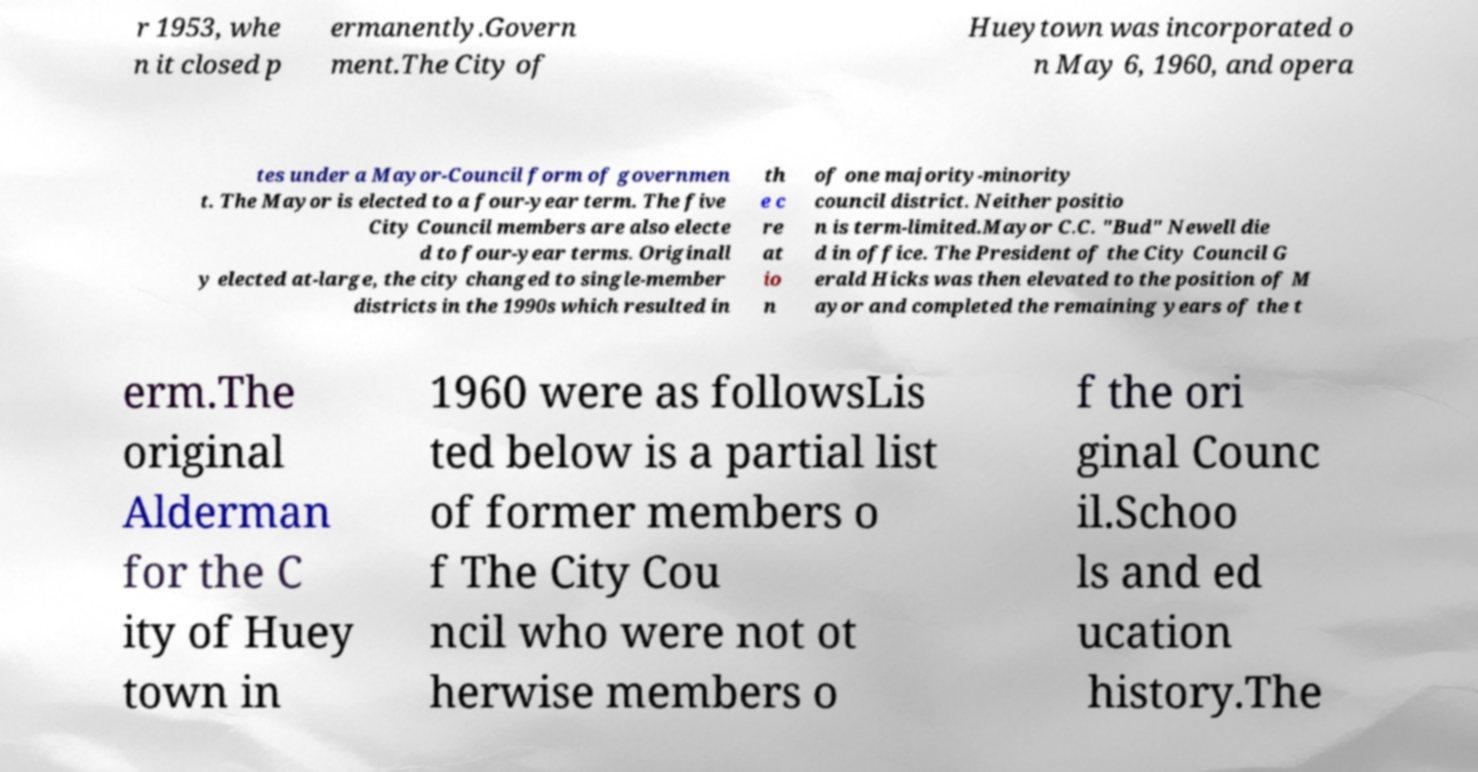Please identify and transcribe the text found in this image. r 1953, whe n it closed p ermanently.Govern ment.The City of Hueytown was incorporated o n May 6, 1960, and opera tes under a Mayor-Council form of governmen t. The Mayor is elected to a four-year term. The five City Council members are also electe d to four-year terms. Originall y elected at-large, the city changed to single-member districts in the 1990s which resulted in th e c re at io n of one majority-minority council district. Neither positio n is term-limited.Mayor C.C. "Bud" Newell die d in office. The President of the City Council G erald Hicks was then elevated to the position of M ayor and completed the remaining years of the t erm.The original Alderman for the C ity of Huey town in 1960 were as followsLis ted below is a partial list of former members o f The City Cou ncil who were not ot herwise members o f the ori ginal Counc il.Schoo ls and ed ucation history.The 